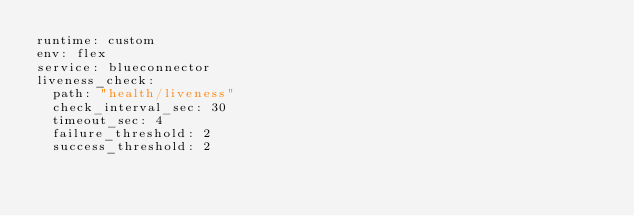Convert code to text. <code><loc_0><loc_0><loc_500><loc_500><_YAML_>runtime: custom
env: flex
service: blueconnector
liveness_check:
  path: "health/liveness"
  check_interval_sec: 30
  timeout_sec: 4
  failure_threshold: 2
  success_threshold: 2</code> 